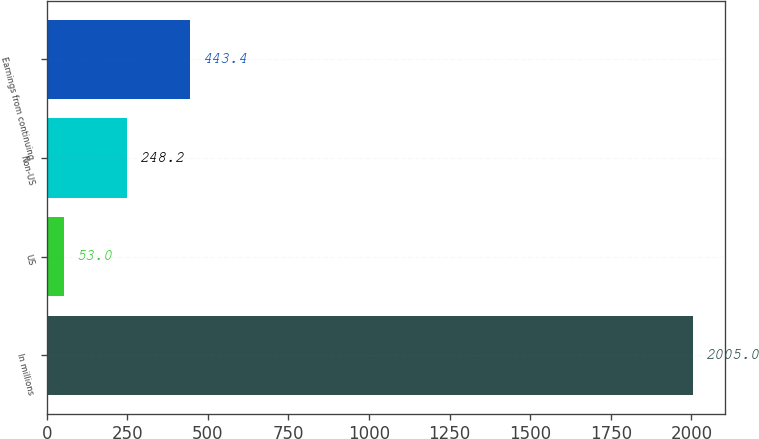Convert chart. <chart><loc_0><loc_0><loc_500><loc_500><bar_chart><fcel>In millions<fcel>US<fcel>Non-US<fcel>Earnings from continuing<nl><fcel>2005<fcel>53<fcel>248.2<fcel>443.4<nl></chart> 